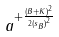Convert formula to latex. <formula><loc_0><loc_0><loc_500><loc_500>a ^ { + \frac { ( B + K ) ^ { 2 } } { 2 { ( s _ { B } ) } ^ { 2 } } }</formula> 